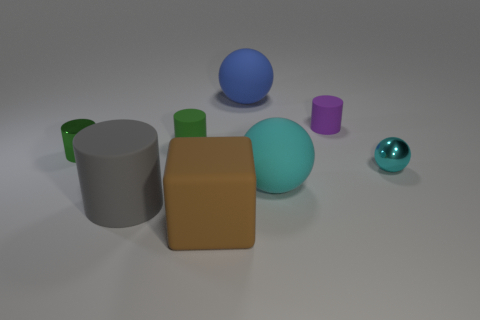Add 2 small shiny objects. How many objects exist? 10 Subtract all cubes. How many objects are left? 7 Subtract 0 red spheres. How many objects are left? 8 Subtract all tiny cyan metal balls. Subtract all small cyan metal spheres. How many objects are left? 6 Add 4 small green metallic objects. How many small green metallic objects are left? 5 Add 8 big red rubber balls. How many big red rubber balls exist? 8 